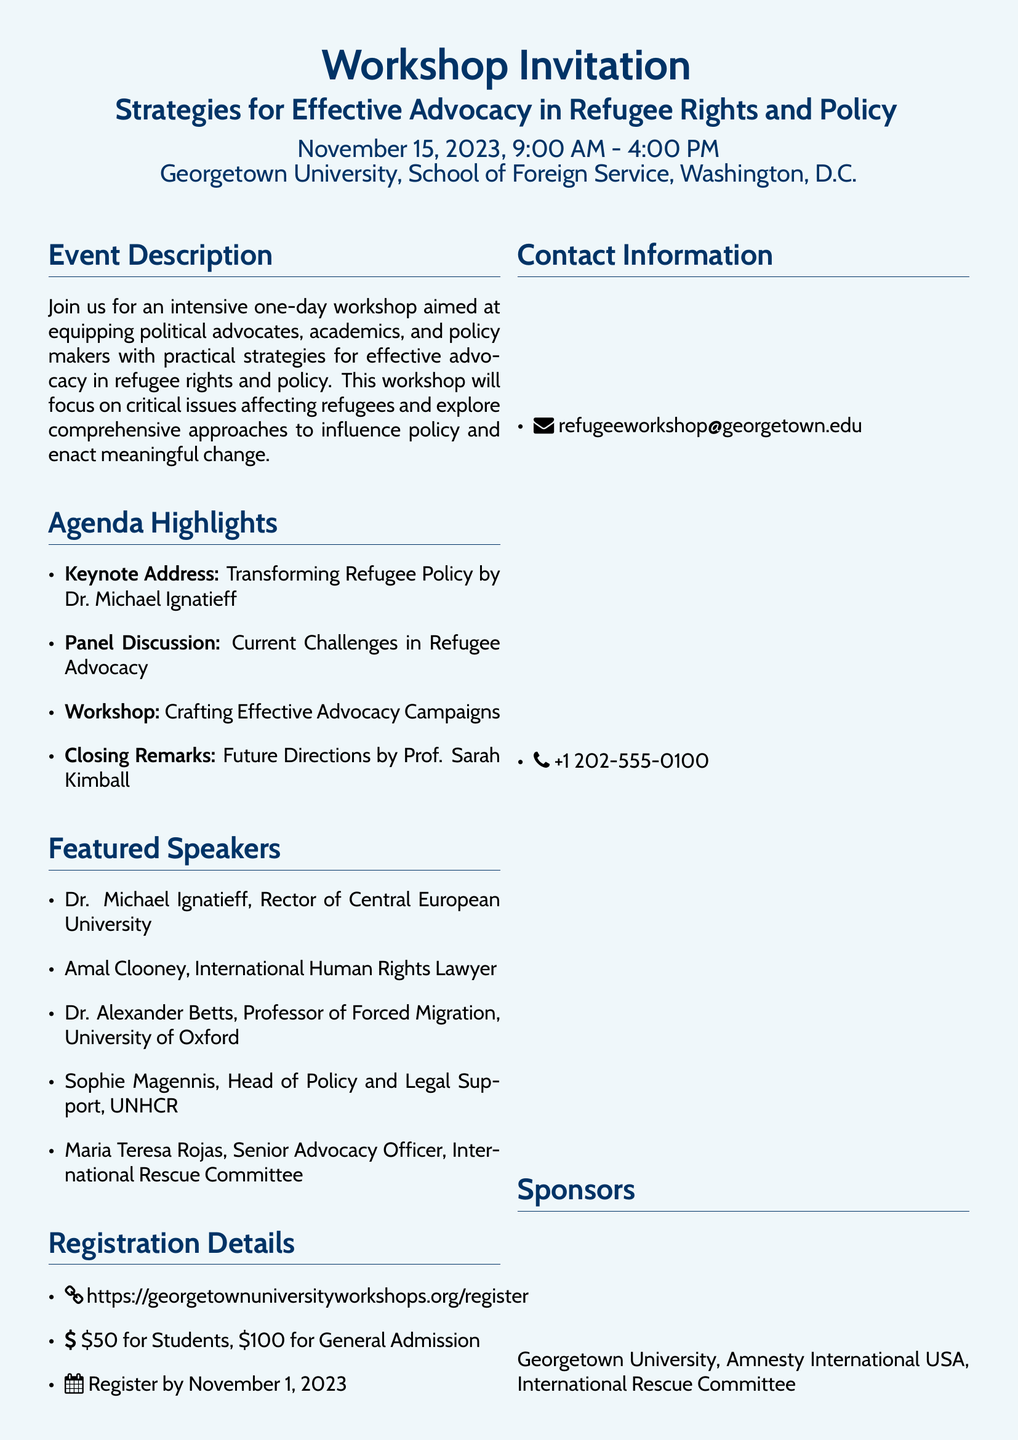what is the date of the workshop? The date is specified in the document as November 15, 2023.
Answer: November 15, 2023 who is the keynote speaker? The keynote speaker is mentioned as Dr. Michael Ignatieff.
Answer: Dr. Michael Ignatieff what is the cost for general admission? The document states the general admission fee is $100.
Answer: $100 where is the workshop being held? The location of the workshop is given as Georgetown University, School of Foreign Service, Washington, D.C.
Answer: Georgetown University, School of Foreign Service, Washington, D.C when is the registration deadline? The registration deadline is noted as November 1, 2023.
Answer: November 1, 2023 what type of event is this document promoting? The event type is identified as a workshop aimed at advocacy in refugee rights and policy.
Answer: workshop who is sponsoring the event? The sponsors listed include Georgetown University, Amnesty International USA, and International Rescue Committee.
Answer: Georgetown University, Amnesty International USA, International Rescue Committee what does the call to action encourage participants to do? The call to action encourages participants to register for the workshop.
Answer: register today 